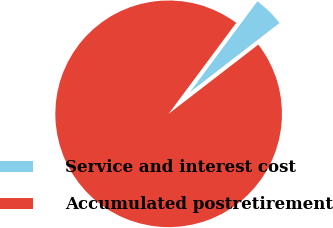Convert chart to OTSL. <chart><loc_0><loc_0><loc_500><loc_500><pie_chart><fcel>Service and interest cost<fcel>Accumulated postretirement<nl><fcel>4.37%<fcel>95.63%<nl></chart> 